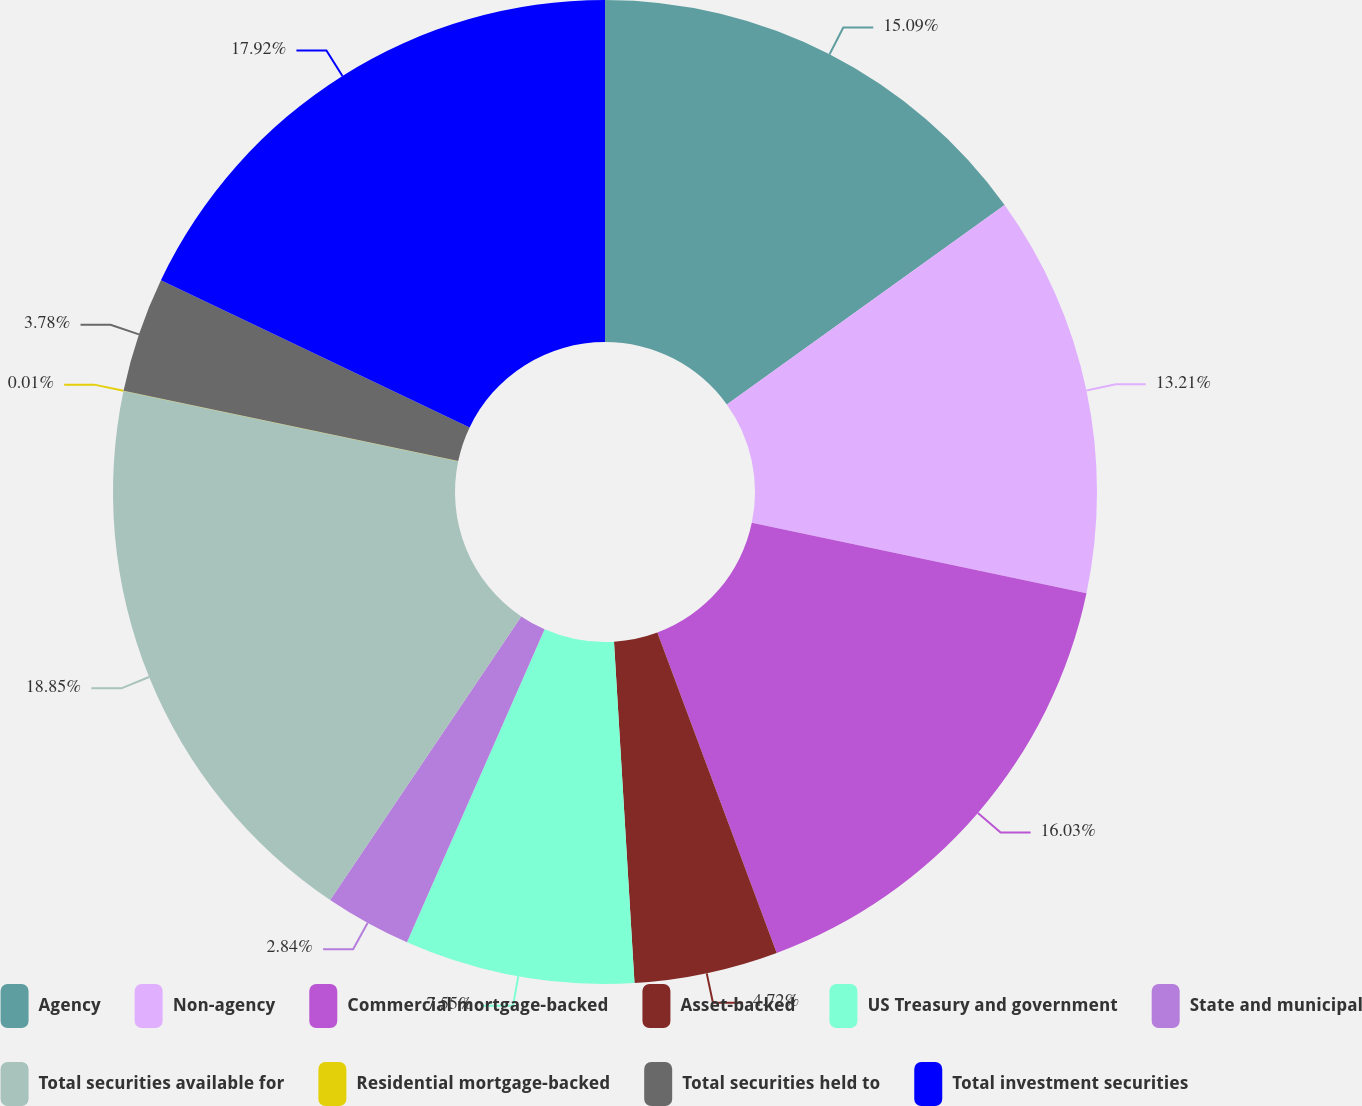Convert chart. <chart><loc_0><loc_0><loc_500><loc_500><pie_chart><fcel>Agency<fcel>Non-agency<fcel>Commercial mortgage-backed<fcel>Asset-backed<fcel>US Treasury and government<fcel>State and municipal<fcel>Total securities available for<fcel>Residential mortgage-backed<fcel>Total securities held to<fcel>Total investment securities<nl><fcel>15.09%<fcel>13.21%<fcel>16.03%<fcel>4.72%<fcel>7.55%<fcel>2.84%<fcel>18.86%<fcel>0.01%<fcel>3.78%<fcel>17.92%<nl></chart> 